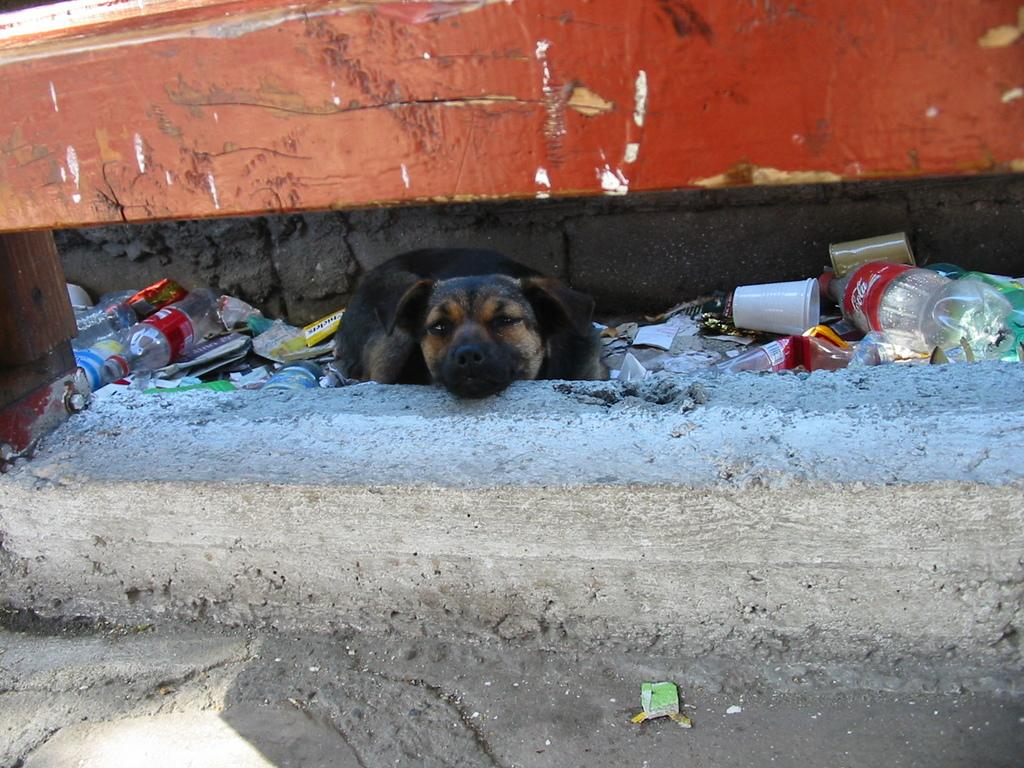What type of animal is in the image? There is a dog in the image. Can you describe the color of the dog? The dog is black and cream colored. What other objects can be seen in the image? There are glasses and bottles in the image. What color is the background wall in the image? The background wall is brown colored. How many girls are playing with the wax in the image? There are no girls or wax present in the image. 